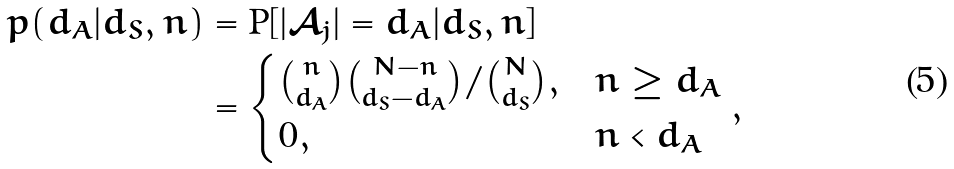<formula> <loc_0><loc_0><loc_500><loc_500>p ( d _ { A } | d _ { S } , n ) & = \text {P} [ | \mathcal { A } _ { j } | = d _ { A } | d _ { S } , n ] \\ & = \begin{cases} { n \choose d _ { A } } { N - n \choose { d _ { S } - d _ { A } } } / { N \choose d _ { S } } , & n \geq d _ { A } \\ 0 , & n < d _ { A } \end{cases} ,</formula> 